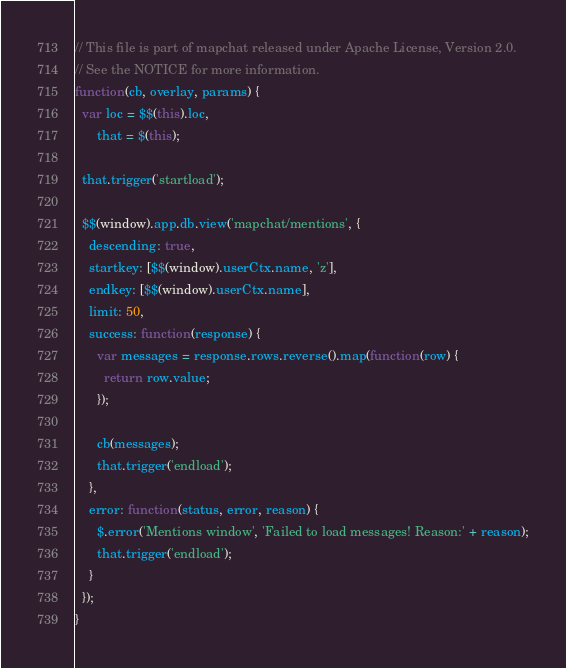<code> <loc_0><loc_0><loc_500><loc_500><_JavaScript_>// This file is part of mapchat released under Apache License, Version 2.0.
// See the NOTICE for more information.
function(cb, overlay, params) {
  var loc = $$(this).loc,
      that = $(this);

  that.trigger('startload');

  $$(window).app.db.view('mapchat/mentions', {
    descending: true,
    startkey: [$$(window).userCtx.name, 'z'],
    endkey: [$$(window).userCtx.name],
    limit: 50,
    success: function(response) {
      var messages = response.rows.reverse().map(function(row) {
        return row.value;
      });

      cb(messages);
      that.trigger('endload');
    },
    error: function(status, error, reason) {
      $.error('Mentions window', 'Failed to load messages! Reason:' + reason);
      that.trigger('endload');
    }
  });
}
</code> 